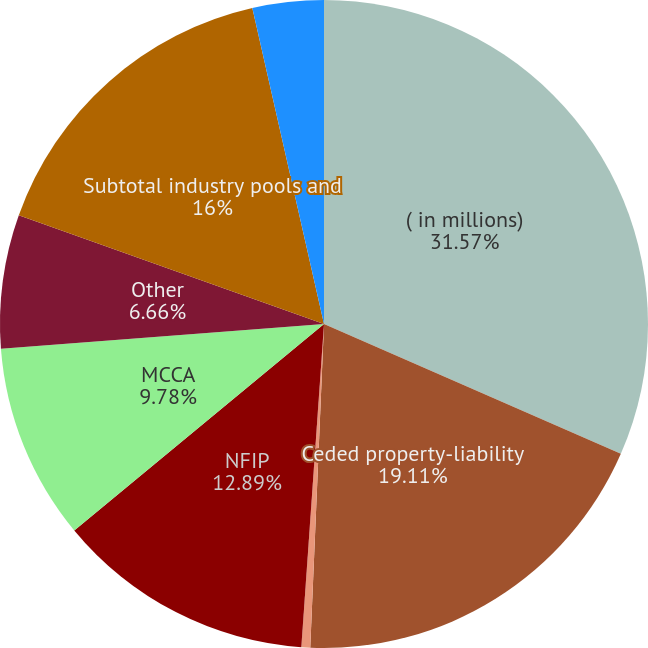Convert chart to OTSL. <chart><loc_0><loc_0><loc_500><loc_500><pie_chart><fcel>( in millions)<fcel>Ceded property-liability<fcel>FHCF<fcel>NFIP<fcel>MCCA<fcel>Other<fcel>Subtotal industry pools and<fcel>Asbestos Environmental and<nl><fcel>31.56%<fcel>19.11%<fcel>0.44%<fcel>12.89%<fcel>9.78%<fcel>6.66%<fcel>16.0%<fcel>3.55%<nl></chart> 